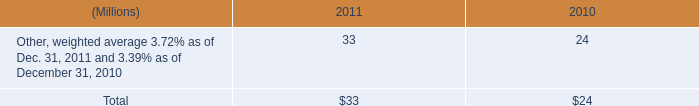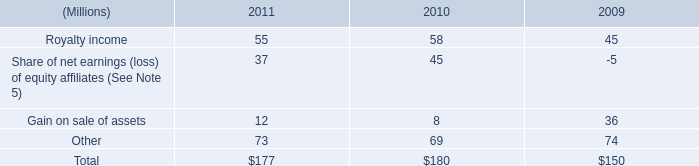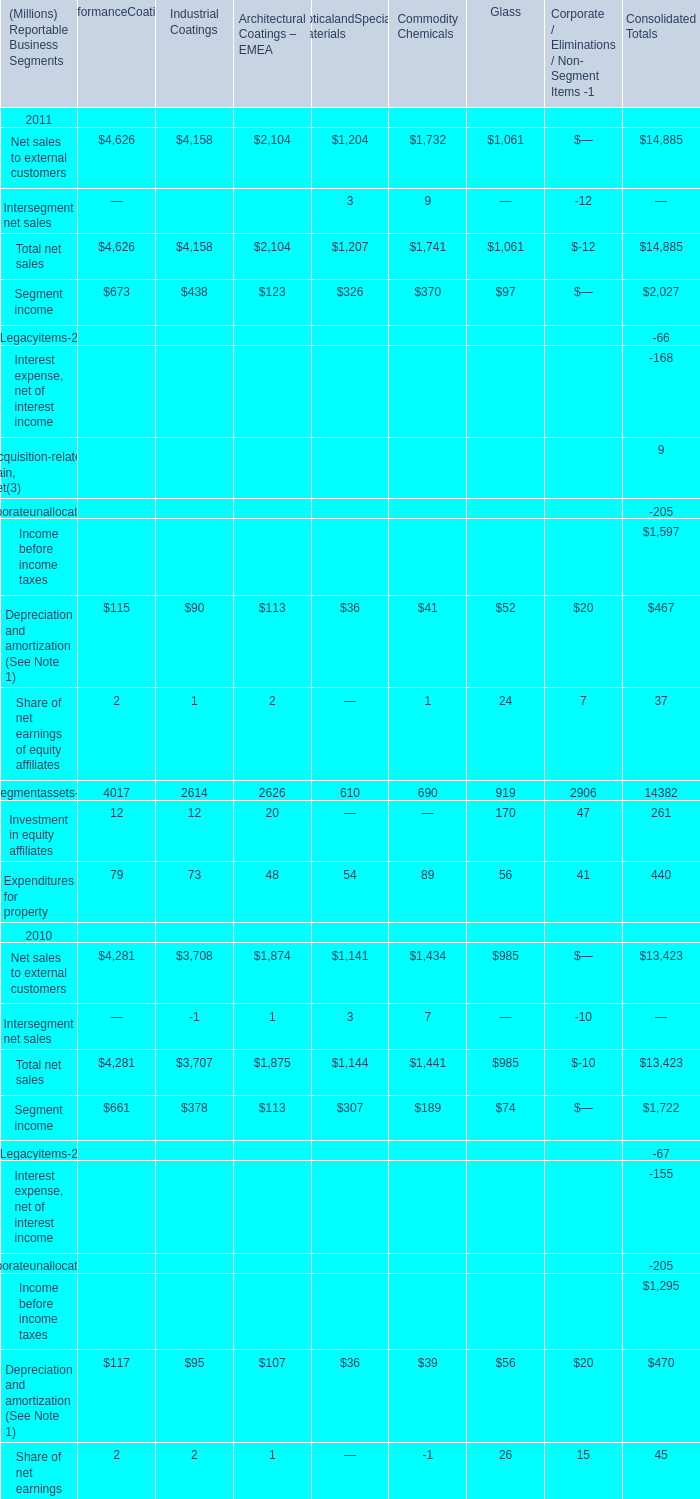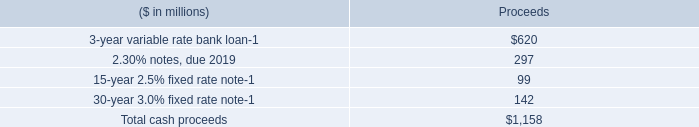what was the percentage change in total interest payments from 2009 to 2010? 
Computations: ((189 - 201) / 201)
Answer: -0.0597. 